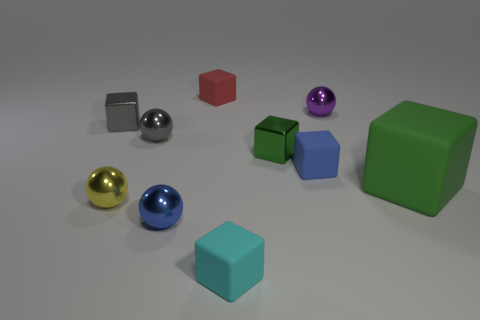Subtract all purple spheres. How many spheres are left? 3 Subtract all green cubes. How many cubes are left? 4 Subtract all brown cylinders. How many green blocks are left? 2 Subtract all balls. How many objects are left? 6 Subtract 3 spheres. How many spheres are left? 1 Subtract 0 red spheres. How many objects are left? 10 Subtract all green cubes. Subtract all red spheres. How many cubes are left? 4 Subtract all big gray metal objects. Subtract all green matte cubes. How many objects are left? 9 Add 6 tiny gray balls. How many tiny gray balls are left? 7 Add 8 tiny purple shiny spheres. How many tiny purple shiny spheres exist? 9 